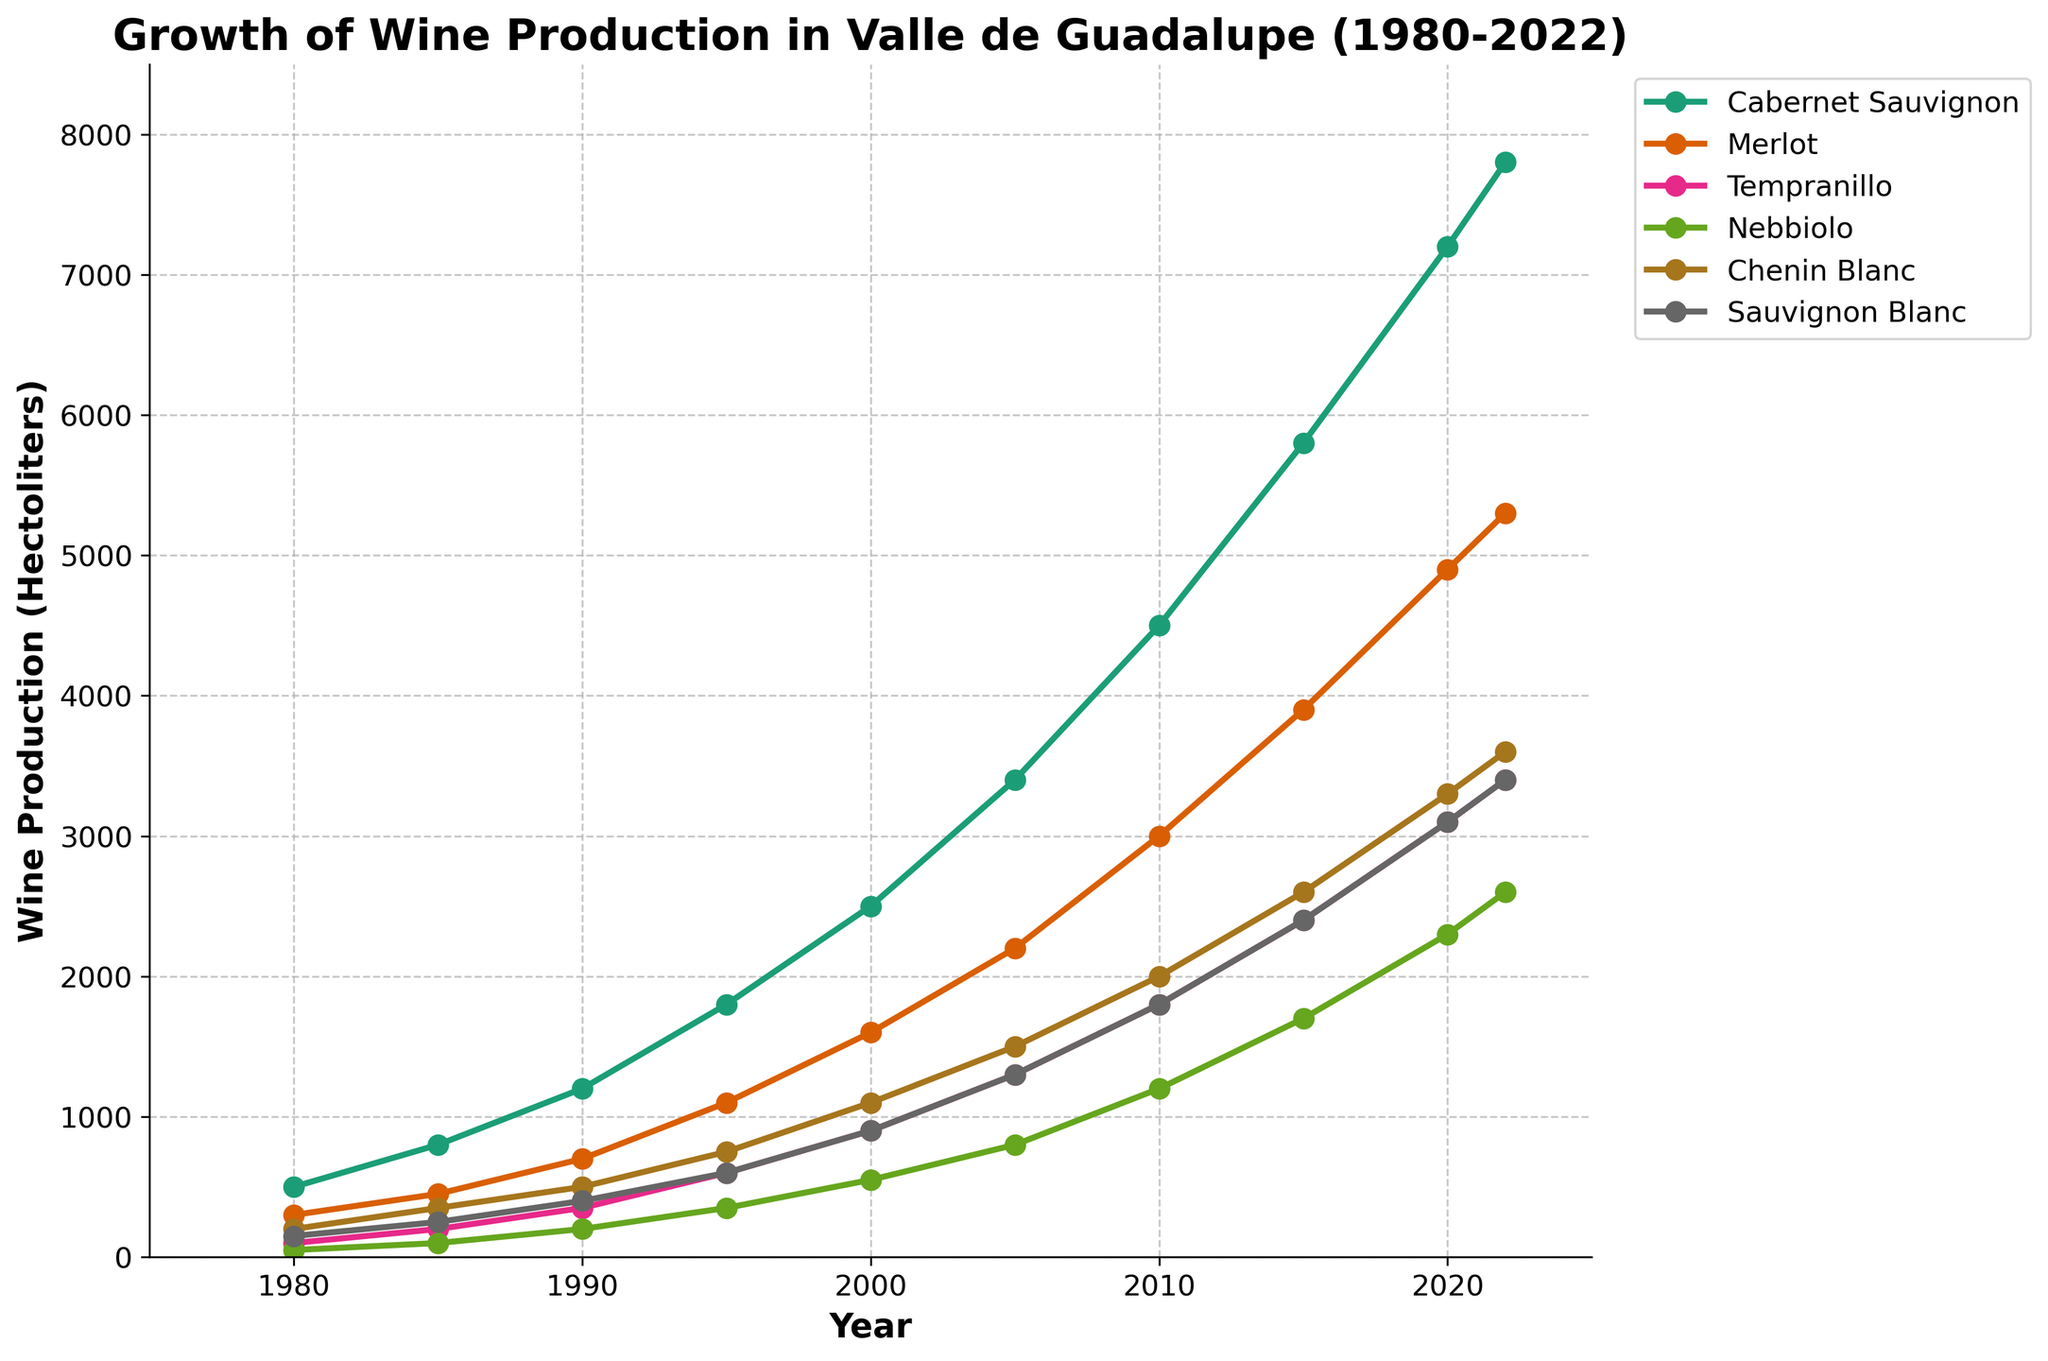Which grape variety had the highest production in 2022? Look at the end points of all the lines in the chart that correspond to the year 2022. Identify the line that ends at the highest position on the y-axis.
Answer: Cabernet Sauvignon By how much did Nebbiolo production increase from 1980 to 2022? Note the production values of Nebbiolo in 1980 and 2022 from the chart. Subtract the 1980 value from the 2022 value.
Answer: 2550 hectoliters Which grape variety displayed the most significant growth in production from 1980 to 2022? Calculate the difference in production for each grape variety between 1980 and 2022. Compare these differences to determine which is the largest.
Answer: Cabernet Sauvignon What was the approximate total production of all grape varieties in Valle de Guadalupe in 1990? Find the production values for all grape varieties in the year 1990. Sum these values together.
Answer: 3350 hectoliters Between which two consecutive years did Tempranillo show the highest growth? Calculate the difference in Tempranillo production between each pair of consecutive recorded years. Identify the pair of years between which the difference is the largest.
Answer: 1985 and 1990 In 2005, did Merlot have higher, lower, or equal production compared to Sauvignon Blanc? Compare the y-values on the plot for Merlot and Sauvignon Blanc at the year 2005.
Answer: Higher What can you infer about the trend observed for Chenin Blanc between 1980 and 2022? Observe the line representing Chenin Blanc in the plot from 1980 to 2022. Assess whether the production increases, decreases, or remains constant.
Answer: Increasing trend Which years have visible production values for Nebbiolo above 1000 hectoliters? Look at the line corresponding to Nebbiolo and identify the years where the production value crosses the 1000 hectoliters mark on the y-axis.
Answer: 2005, 2010, 2015, 2020, 2022 What is the average production of Cabernet Sauvignon over the recorded years? Sum the production values of Cabernet Sauvignon for all the recorded years and divide the sum by the number of recorded years.
Answer: 3722 hectoliters By how much did Sauvignon Blanc production increase between 2000 and 2010? Note the production values of Sauvignon Blanc in 2000 and 2010 from the chart. Subtract the 2000 value from the 2010 value.
Answer: 900 hectoliters 